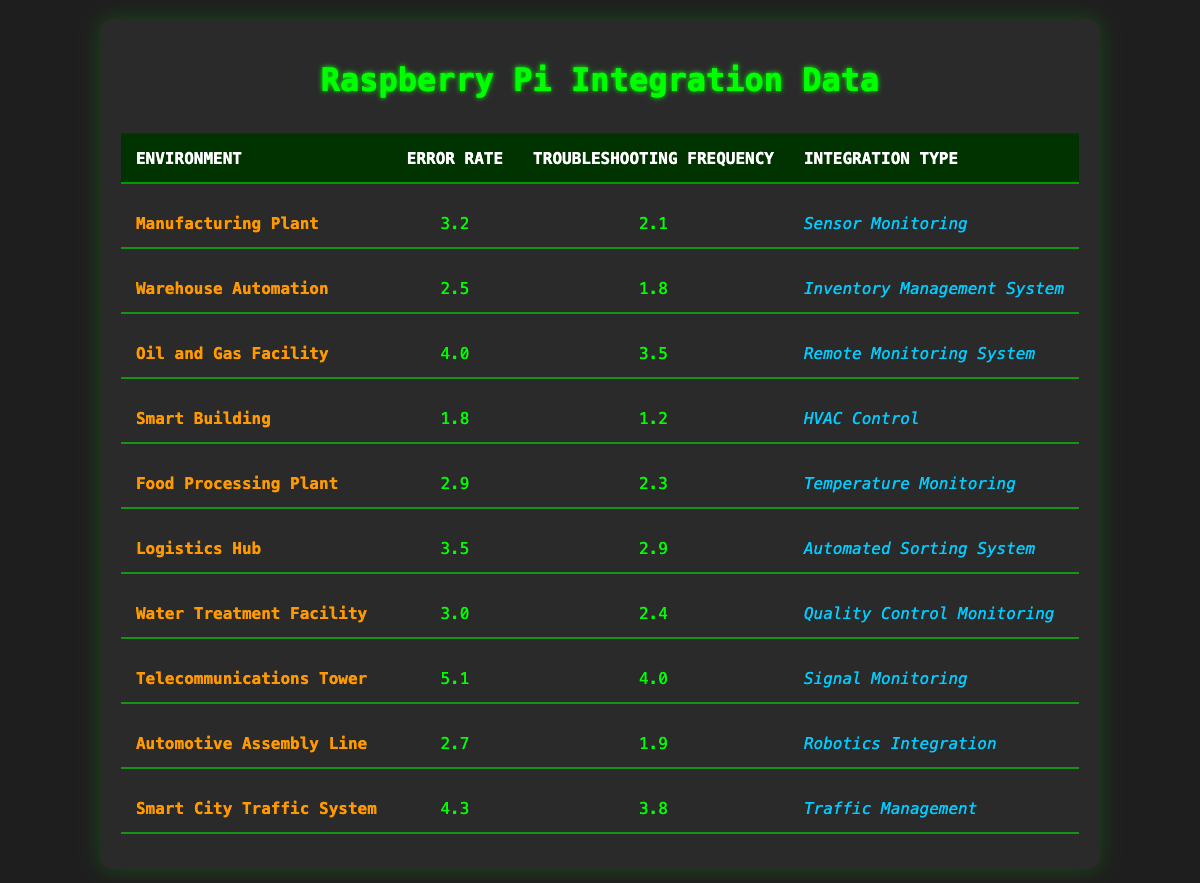What is the error rate for the Smart Building environment? The Smart Building environment has an error rate of 1.8, which can be found in the corresponding row under the "Error Rate" column.
Answer: 1.8 Which integration type has the highest error rate? The integration type with the highest error rate is "Signal Monitoring" in the Telecommunications Tower environment, which has an error rate of 5.1.
Answer: Signal Monitoring What is the troubleshooting frequency for the Oil and Gas Facility? The troubleshooting frequency for the Oil and Gas Facility is 3.5. This information is located in the respective row under the "Troubleshooting Frequency" column.
Answer: 3.5 Is the error rate for the Food Processing Plant greater than that of the Smart Building? Yes, the error rate for the Food Processing Plant is 2.9, which is greater than the Smart Building's error rate of 1.8.
Answer: Yes What is the average error rate across all environments? To calculate the average error rate, we sum all the error rates: (3.2 + 2.5 + 4.0 + 1.8 + 2.9 + 3.5 + 3.0 + 5.1 + 2.7 + 4.3) = 33.0. There are 10 environments, so the average is 33.0 / 10 = 3.3.
Answer: 3.3 Which environment has the lowest troubleshooting frequency, and what is the value? The environment with the lowest troubleshooting frequency is "Smart Building," which has a troubleshooting frequency of 1.2. This is seen in the "Troubleshooting Frequency" column for that row.
Answer: Smart Building, 1.2 Which two integrations with the highest error rates also show a high troubleshooting frequency? The two integrations are "Signal Monitoring" at 5.1 (Telecommunications Tower) and "Traffic Management" at 4.3 (Smart City Traffic System). Both have high error rates and troubleshooting frequencies.
Answer: Signal Monitoring, Traffic Management What is the difference in troubleshooting frequency between the Oil and Gas Facility and the Warehouse Automation? The troubleshooting frequency for the Oil and Gas Facility is 3.5, and for Warehouse Automation, it is 1.8. The difference is 3.5 - 1.8 = 1.7.
Answer: 1.7 Which environments have an error rate above 3.0? The environments with an error rate above 3.0 are "Oil and Gas Facility" (4.0), "Telecommunications Tower" (5.1), "Smart City Traffic System" (4.3), and "Logistics Hub" (3.5). This can be identified by examining the error rates in each row.
Answer: Oil and Gas Facility, Telecommunications Tower, Smart City Traffic System, Logistics Hub Is the average troubleshooting frequency for environments with error rates less than 3.0 greater than 2.0? To answer this, we first identify the environments with error rates less than 3.0: Smart Building (1.2), Warehouse Automation (1.8), and Food Processing Plant (2.3). The troubleshooting frequencies for these are 1.2, 1.8, and 2.3, respectively. Their average is: (1.2 + 1.8 + 2.3) / 3 = 1.767, which is less than 2.0.
Answer: No 